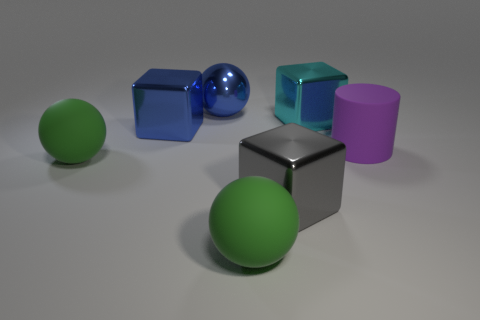Add 1 big purple matte spheres. How many objects exist? 8 Subtract all balls. How many objects are left? 4 Subtract all blue things. Subtract all spheres. How many objects are left? 2 Add 4 large blue cubes. How many large blue cubes are left? 5 Add 3 gray cubes. How many gray cubes exist? 4 Subtract 0 green cylinders. How many objects are left? 7 